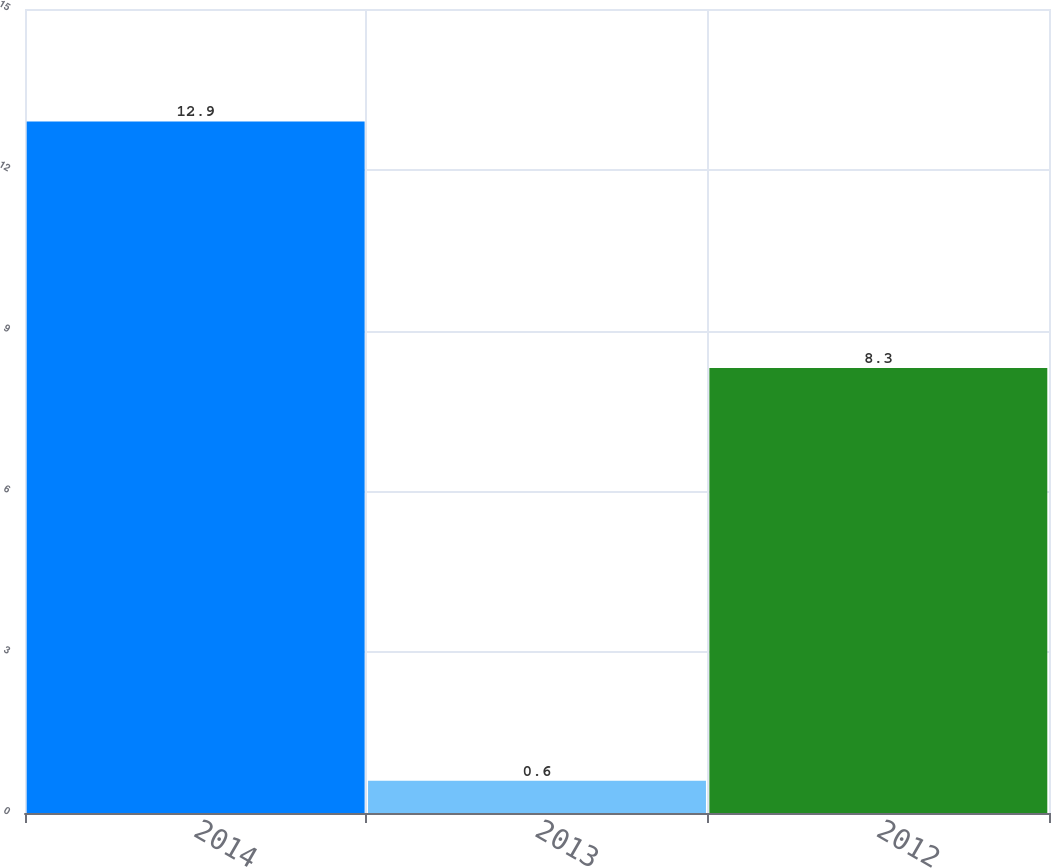<chart> <loc_0><loc_0><loc_500><loc_500><bar_chart><fcel>2014<fcel>2013<fcel>2012<nl><fcel>12.9<fcel>0.6<fcel>8.3<nl></chart> 